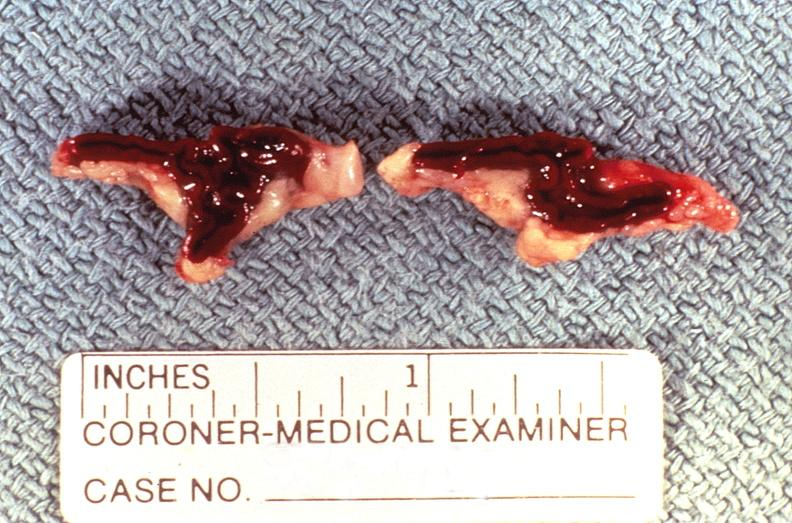does this image show adrenal gland, severe hemorrhage waterhouse-friderichsen syndrome?
Answer the question using a single word or phrase. Yes 